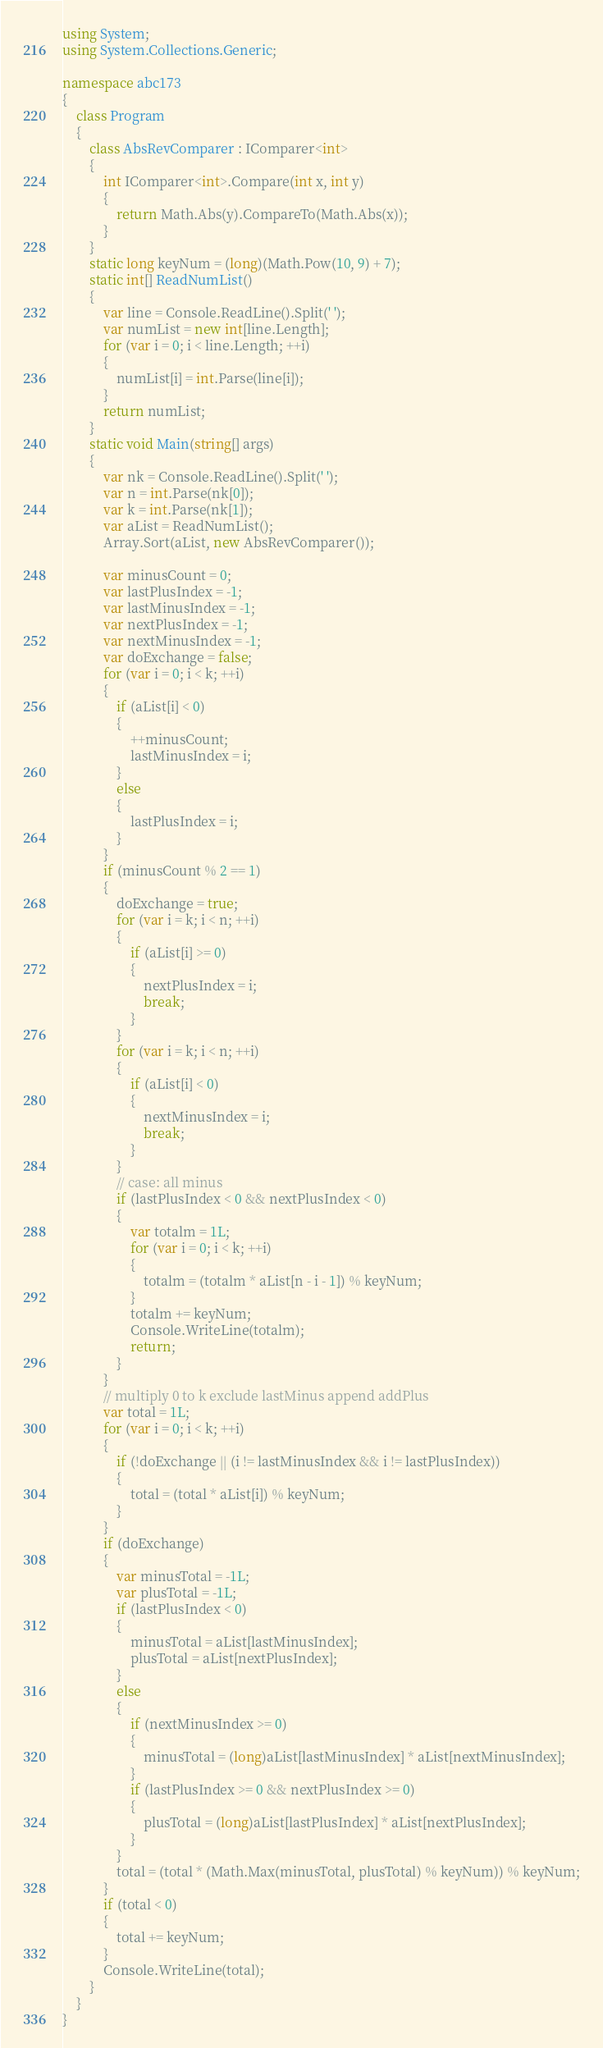<code> <loc_0><loc_0><loc_500><loc_500><_C#_>using System;
using System.Collections.Generic;

namespace abc173
{
    class Program
    {
        class AbsRevComparer : IComparer<int>
        {
            int IComparer<int>.Compare(int x, int y)
            {
                return Math.Abs(y).CompareTo(Math.Abs(x));
            }
        }
        static long keyNum = (long)(Math.Pow(10, 9) + 7);
        static int[] ReadNumList()
        {
            var line = Console.ReadLine().Split(' ');
            var numList = new int[line.Length];
            for (var i = 0; i < line.Length; ++i)
            {
                numList[i] = int.Parse(line[i]);
            }
            return numList;
        }
        static void Main(string[] args)
        {
            var nk = Console.ReadLine().Split(' ');
            var n = int.Parse(nk[0]);
            var k = int.Parse(nk[1]);
            var aList = ReadNumList();
            Array.Sort(aList, new AbsRevComparer());

            var minusCount = 0;
            var lastPlusIndex = -1;
            var lastMinusIndex = -1;
            var nextPlusIndex = -1;
            var nextMinusIndex = -1;
            var doExchange = false;
            for (var i = 0; i < k; ++i)
            {
                if (aList[i] < 0)
                {
                    ++minusCount;
                    lastMinusIndex = i;
                }
                else
                {
                    lastPlusIndex = i;
                }
            }
            if (minusCount % 2 == 1)
            {
                doExchange = true;
                for (var i = k; i < n; ++i)
                {
                    if (aList[i] >= 0)
                    {
                        nextPlusIndex = i;
                        break;
                    }
                }
                for (var i = k; i < n; ++i)
                {
                    if (aList[i] < 0)
                    {
                        nextMinusIndex = i;
                        break;
                    }
                }
                // case: all minus
                if (lastPlusIndex < 0 && nextPlusIndex < 0)
                {
                    var totalm = 1L;
                    for (var i = 0; i < k; ++i)
                    {
                        totalm = (totalm * aList[n - i - 1]) % keyNum;
                    }
                    totalm += keyNum;
                    Console.WriteLine(totalm);
                    return;
                }
            }
            // multiply 0 to k exclude lastMinus append addPlus
            var total = 1L;
            for (var i = 0; i < k; ++i)
            {
                if (!doExchange || (i != lastMinusIndex && i != lastPlusIndex))
                {
                    total = (total * aList[i]) % keyNum;
                }
            }
            if (doExchange)
            {
                var minusTotal = -1L;
                var plusTotal = -1L;
                if (lastPlusIndex < 0)
                {
                    minusTotal = aList[lastMinusIndex];
                    plusTotal = aList[nextPlusIndex];
                }
                else
                {
                    if (nextMinusIndex >= 0)
                    {
                        minusTotal = (long)aList[lastMinusIndex] * aList[nextMinusIndex];
                    }
                    if (lastPlusIndex >= 0 && nextPlusIndex >= 0)
                    {
                        plusTotal = (long)aList[lastPlusIndex] * aList[nextPlusIndex];
                    }
                }
                total = (total * (Math.Max(minusTotal, plusTotal) % keyNum)) % keyNum;
            }
            if (total < 0)
            {
                total += keyNum;
            }
            Console.WriteLine(total);
        }
    }
}
</code> 